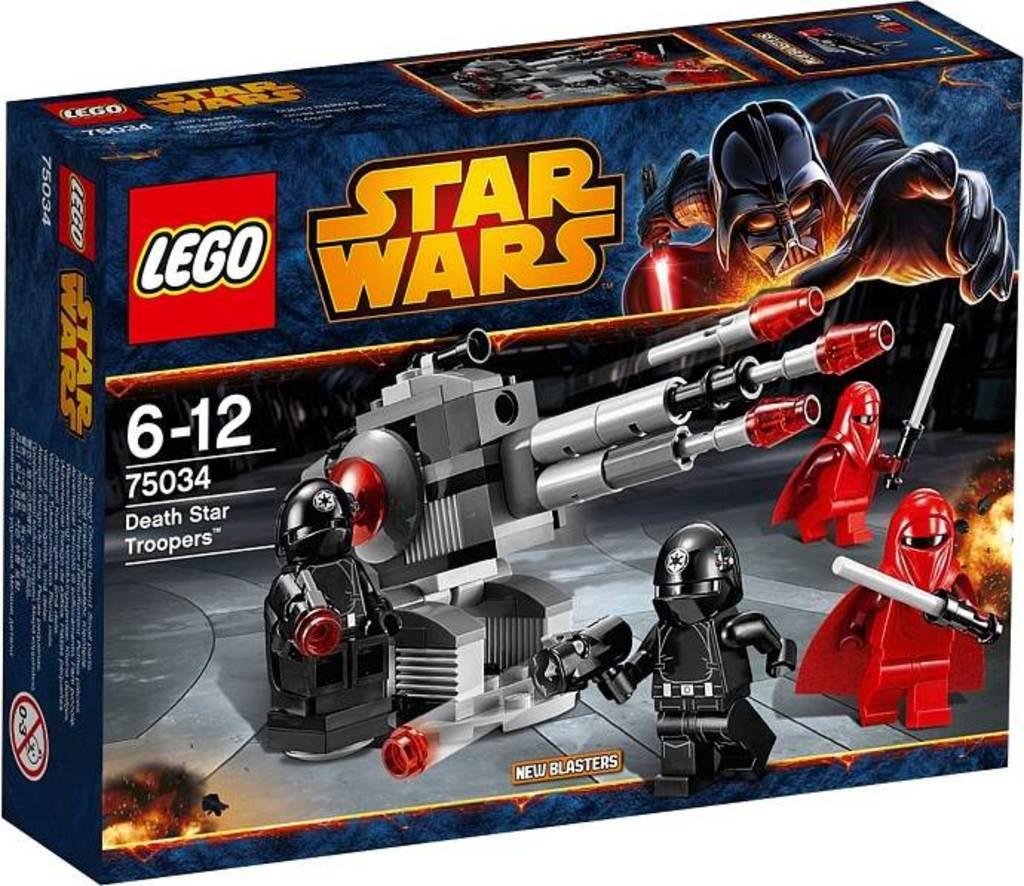What kind of legos is this?
Your response must be concise. Star wars. What kind of star wars toy is this?
Provide a short and direct response. Death star troopers. 